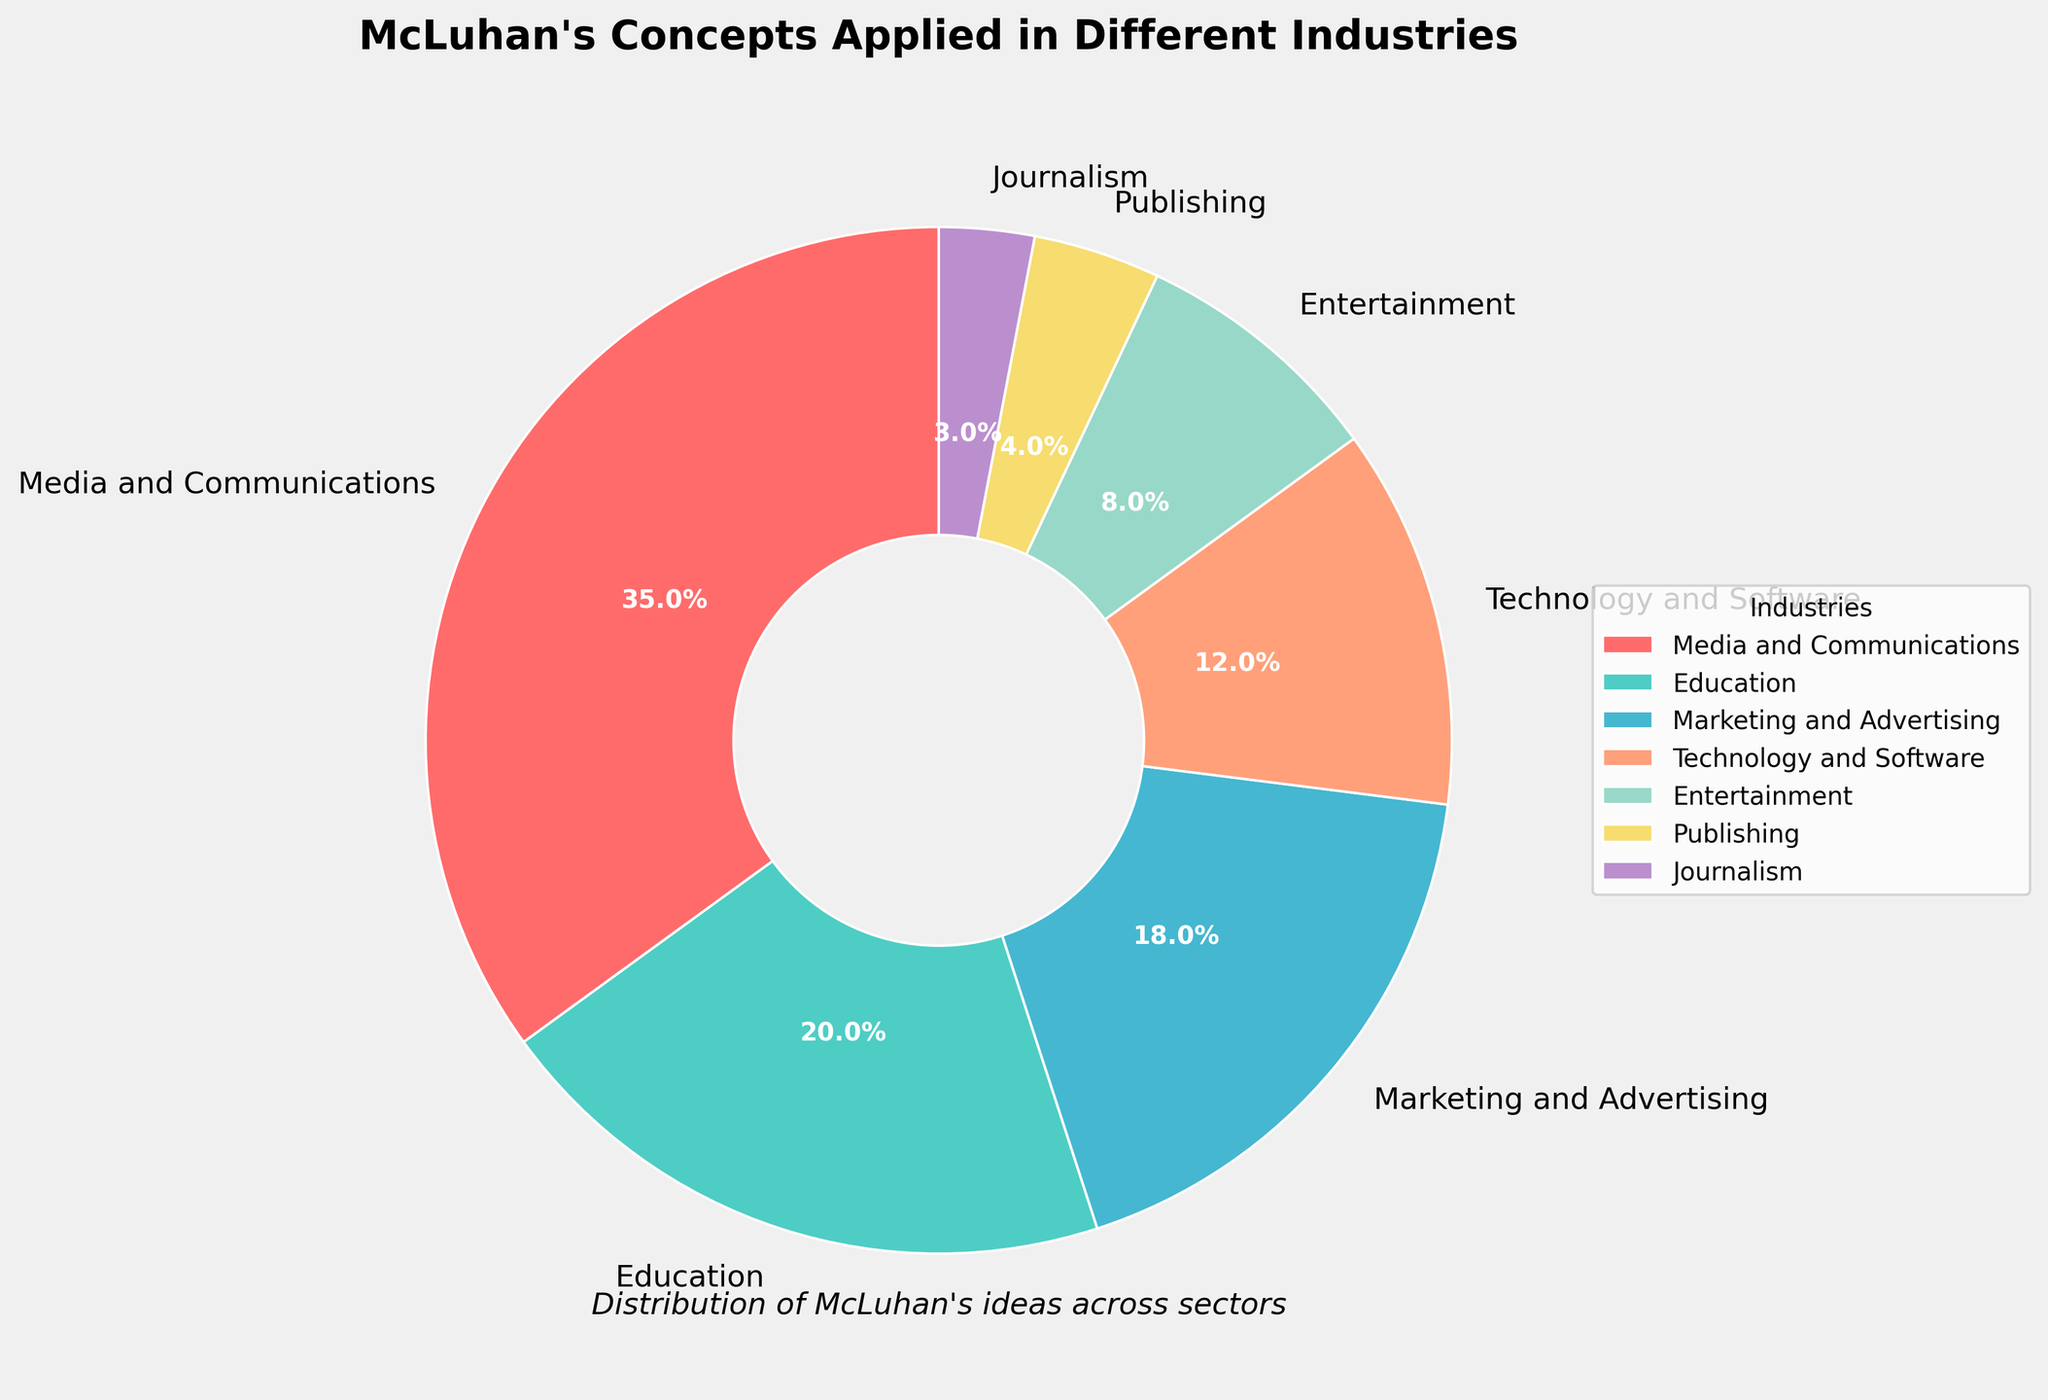Which industry has the highest percentage of McLuhan's concepts applied? Look at the pie chart and identify the section with the largest percentage. The largest section is labeled "Media and Communications" with 35%.
Answer: Media and Communications How much more percentage of McLuhan's concepts is applied in Media and Communications compared to Marketing and Advertising? The percentage for Media and Communications is 35%, and for Marketing and Advertising, it is 18%. Subtract 18 from 35 to get the difference. 35 - 18 = 17
Answer: 17% What is the combined percentage of McLuhan's concepts applied in Technology and Software, and Entertainment? Add the percentages for Technology and Software and Entertainment. Technology and Software has 12%, and Entertainment has 8%. 12 + 8 = 20
Answer: 20% Which industries have less than 10% of McLuhan's concepts applied? Identify the sections in the pie chart with percentages below 10%. These are "Entertainment" with 8%, "Publishing" with 4%, and "Journalism" with 3%.
Answer: Entertainment, Publishing, Journalism What is the average percentage of McLuhan's concepts applied across all industries? Add up all the percentages and divide by the number of industries. (35 + 20 + 18 + 12 + 8 + 4 + 3) / 7 = 100 / 7 ≈ 14.29
Answer: ~14.29% Which section of the pie chart is represented by the color red? Visually identify the section colored in red. The section labeled is "Media and Communications" with 35%.
Answer: Media and Communications How much greater is the percentage of McLuhan's concepts in Education compared to Journalism? Subtract the percentage of Journalism from Education. 20% (Education) - 3% (Journalism) = 17%
Answer: 17% Are there any industries with equal percentages? Refer to the pie chart to compare the percentages of different industries. There are no industries with equal percentages listed.
Answer: No What percentage of McLuhan's concepts is applied in the smallest industry? Identify the section with the smallest percentage in the pie chart. "Journalism" has the smallest percentage with 3%.
Answer: 3% 